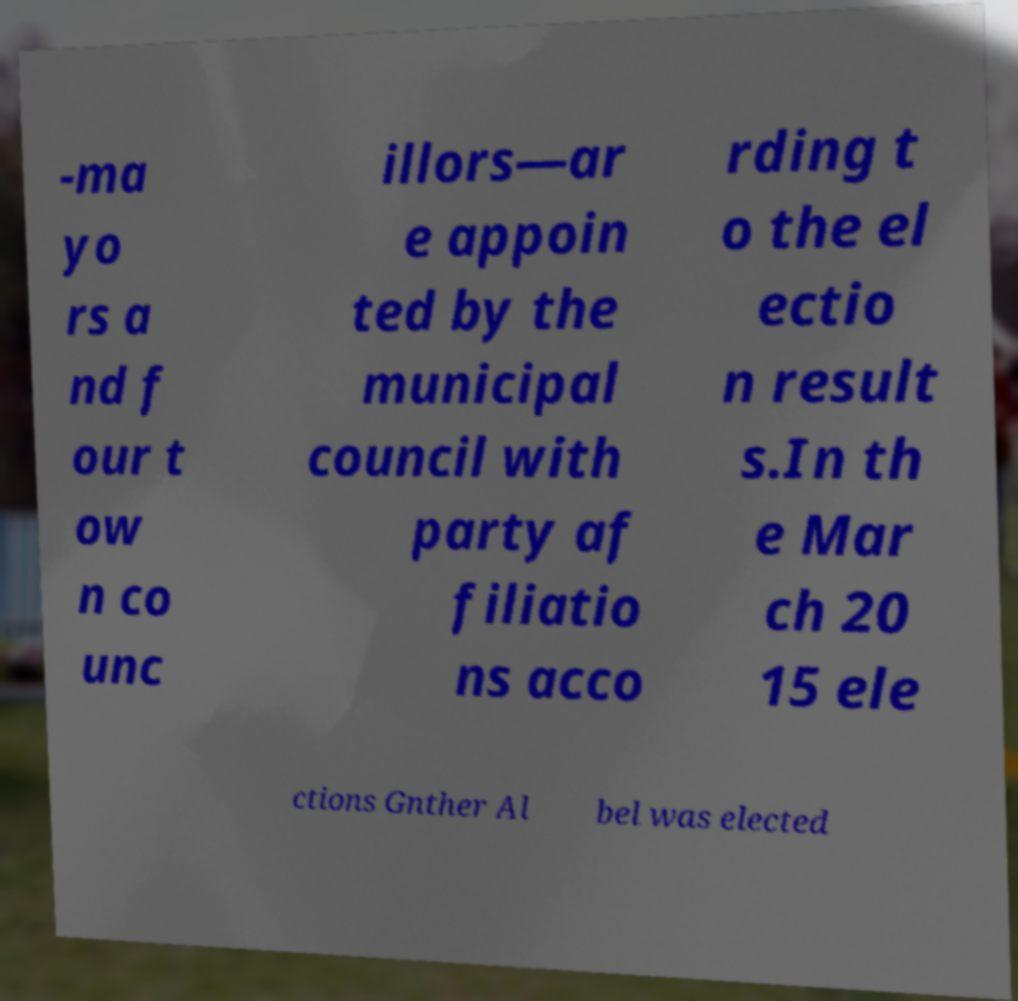I need the written content from this picture converted into text. Can you do that? -ma yo rs a nd f our t ow n co unc illors—ar e appoin ted by the municipal council with party af filiatio ns acco rding t o the el ectio n result s.In th e Mar ch 20 15 ele ctions Gnther Al bel was elected 